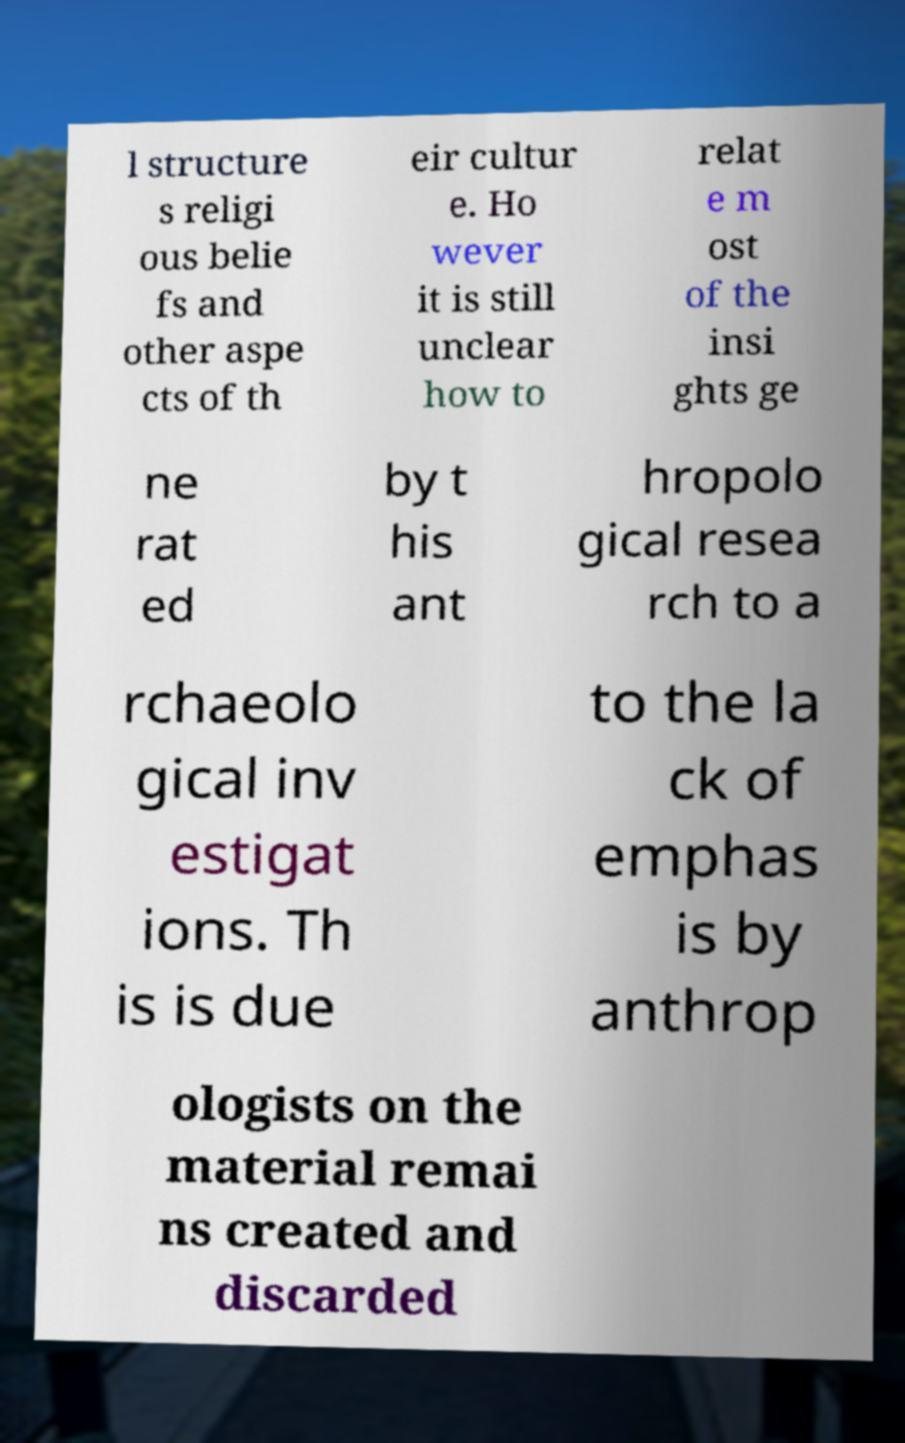Can you read and provide the text displayed in the image?This photo seems to have some interesting text. Can you extract and type it out for me? l structure s religi ous belie fs and other aspe cts of th eir cultur e. Ho wever it is still unclear how to relat e m ost of the insi ghts ge ne rat ed by t his ant hropolo gical resea rch to a rchaeolo gical inv estigat ions. Th is is due to the la ck of emphas is by anthrop ologists on the material remai ns created and discarded 